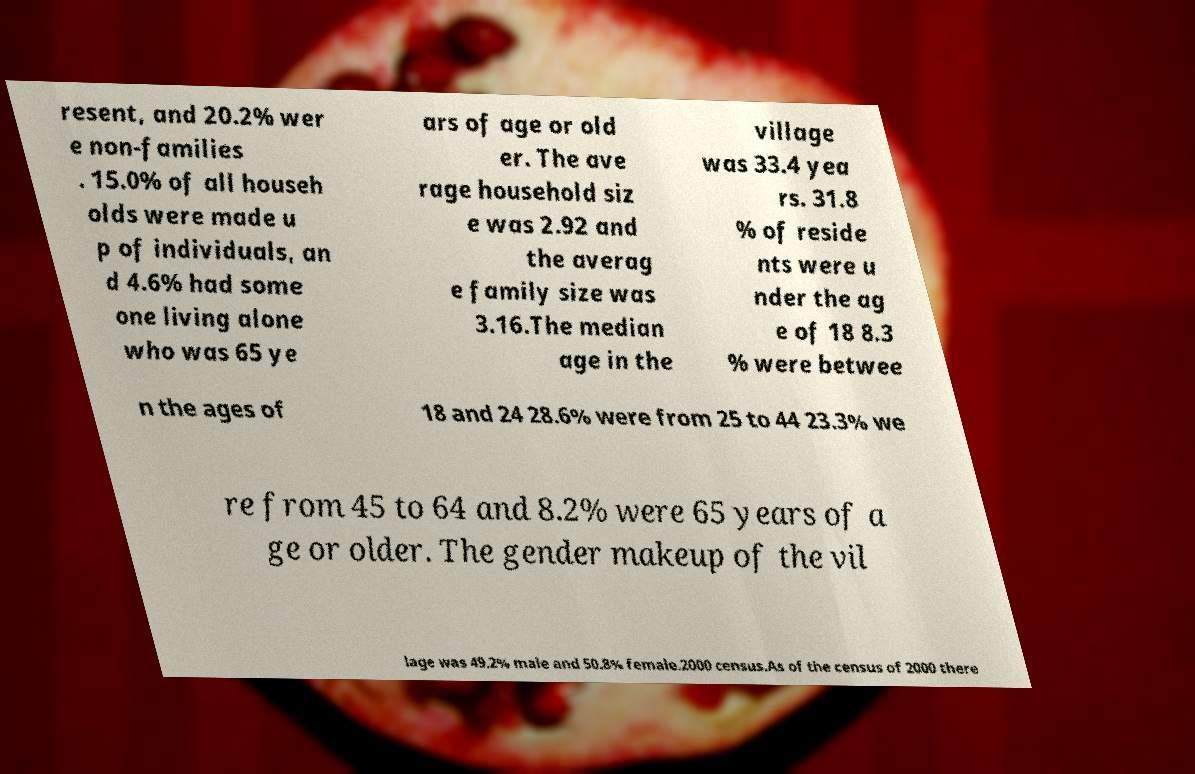There's text embedded in this image that I need extracted. Can you transcribe it verbatim? resent, and 20.2% wer e non-families . 15.0% of all househ olds were made u p of individuals, an d 4.6% had some one living alone who was 65 ye ars of age or old er. The ave rage household siz e was 2.92 and the averag e family size was 3.16.The median age in the village was 33.4 yea rs. 31.8 % of reside nts were u nder the ag e of 18 8.3 % were betwee n the ages of 18 and 24 28.6% were from 25 to 44 23.3% we re from 45 to 64 and 8.2% were 65 years of a ge or older. The gender makeup of the vil lage was 49.2% male and 50.8% female.2000 census.As of the census of 2000 there 